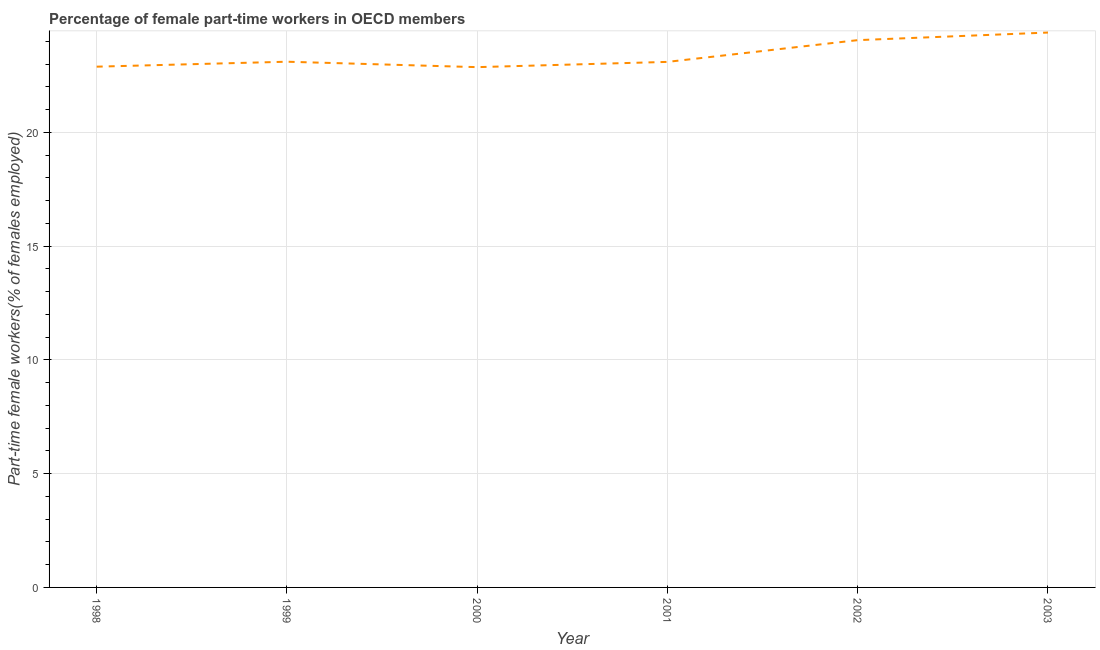What is the percentage of part-time female workers in 1998?
Your answer should be compact. 22.88. Across all years, what is the maximum percentage of part-time female workers?
Provide a succinct answer. 24.38. Across all years, what is the minimum percentage of part-time female workers?
Your response must be concise. 22.86. In which year was the percentage of part-time female workers maximum?
Your answer should be very brief. 2003. What is the sum of the percentage of part-time female workers?
Your answer should be compact. 140.38. What is the difference between the percentage of part-time female workers in 1999 and 2003?
Provide a succinct answer. -1.28. What is the average percentage of part-time female workers per year?
Your answer should be compact. 23.4. What is the median percentage of part-time female workers?
Provide a short and direct response. 23.1. What is the ratio of the percentage of part-time female workers in 2000 to that in 2002?
Your response must be concise. 0.95. Is the difference between the percentage of part-time female workers in 1999 and 2000 greater than the difference between any two years?
Make the answer very short. No. What is the difference between the highest and the second highest percentage of part-time female workers?
Keep it short and to the point. 0.33. What is the difference between the highest and the lowest percentage of part-time female workers?
Offer a terse response. 1.52. Does the percentage of part-time female workers monotonically increase over the years?
Your answer should be very brief. No. How many years are there in the graph?
Make the answer very short. 6. Are the values on the major ticks of Y-axis written in scientific E-notation?
Offer a very short reply. No. Does the graph contain any zero values?
Your answer should be compact. No. What is the title of the graph?
Your response must be concise. Percentage of female part-time workers in OECD members. What is the label or title of the X-axis?
Keep it short and to the point. Year. What is the label or title of the Y-axis?
Offer a terse response. Part-time female workers(% of females employed). What is the Part-time female workers(% of females employed) of 1998?
Your answer should be very brief. 22.88. What is the Part-time female workers(% of females employed) of 1999?
Provide a succinct answer. 23.1. What is the Part-time female workers(% of females employed) in 2000?
Offer a very short reply. 22.86. What is the Part-time female workers(% of females employed) of 2001?
Your answer should be very brief. 23.09. What is the Part-time female workers(% of females employed) in 2002?
Offer a very short reply. 24.05. What is the Part-time female workers(% of females employed) in 2003?
Provide a succinct answer. 24.38. What is the difference between the Part-time female workers(% of females employed) in 1998 and 1999?
Your response must be concise. -0.22. What is the difference between the Part-time female workers(% of females employed) in 1998 and 2000?
Provide a short and direct response. 0.02. What is the difference between the Part-time female workers(% of females employed) in 1998 and 2001?
Keep it short and to the point. -0.21. What is the difference between the Part-time female workers(% of females employed) in 1998 and 2002?
Your answer should be compact. -1.17. What is the difference between the Part-time female workers(% of females employed) in 1998 and 2003?
Make the answer very short. -1.5. What is the difference between the Part-time female workers(% of females employed) in 1999 and 2000?
Give a very brief answer. 0.24. What is the difference between the Part-time female workers(% of females employed) in 1999 and 2001?
Provide a short and direct response. 0.01. What is the difference between the Part-time female workers(% of females employed) in 1999 and 2002?
Your response must be concise. -0.95. What is the difference between the Part-time female workers(% of females employed) in 1999 and 2003?
Keep it short and to the point. -1.28. What is the difference between the Part-time female workers(% of females employed) in 2000 and 2001?
Provide a short and direct response. -0.23. What is the difference between the Part-time female workers(% of females employed) in 2000 and 2002?
Provide a short and direct response. -1.19. What is the difference between the Part-time female workers(% of females employed) in 2000 and 2003?
Give a very brief answer. -1.52. What is the difference between the Part-time female workers(% of females employed) in 2001 and 2002?
Keep it short and to the point. -0.96. What is the difference between the Part-time female workers(% of females employed) in 2001 and 2003?
Ensure brevity in your answer.  -1.29. What is the difference between the Part-time female workers(% of females employed) in 2002 and 2003?
Provide a short and direct response. -0.33. What is the ratio of the Part-time female workers(% of females employed) in 1998 to that in 2001?
Provide a succinct answer. 0.99. What is the ratio of the Part-time female workers(% of females employed) in 1998 to that in 2003?
Your answer should be compact. 0.94. What is the ratio of the Part-time female workers(% of females employed) in 1999 to that in 2000?
Ensure brevity in your answer.  1.01. What is the ratio of the Part-time female workers(% of females employed) in 1999 to that in 2003?
Provide a short and direct response. 0.95. What is the ratio of the Part-time female workers(% of females employed) in 2000 to that in 2001?
Offer a very short reply. 0.99. What is the ratio of the Part-time female workers(% of females employed) in 2000 to that in 2002?
Offer a terse response. 0.95. What is the ratio of the Part-time female workers(% of females employed) in 2000 to that in 2003?
Your response must be concise. 0.94. What is the ratio of the Part-time female workers(% of females employed) in 2001 to that in 2003?
Provide a short and direct response. 0.95. What is the ratio of the Part-time female workers(% of females employed) in 2002 to that in 2003?
Provide a succinct answer. 0.99. 